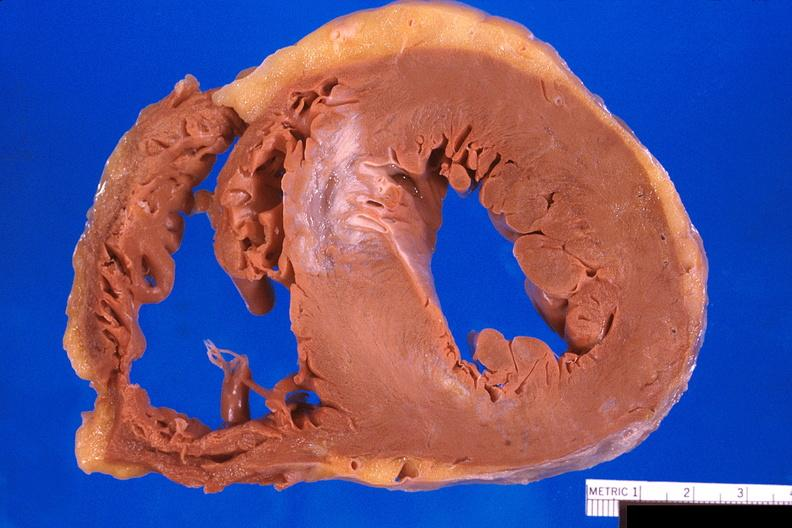does this image show heart, old myocardial infarction with fibrosis?
Answer the question using a single word or phrase. Yes 